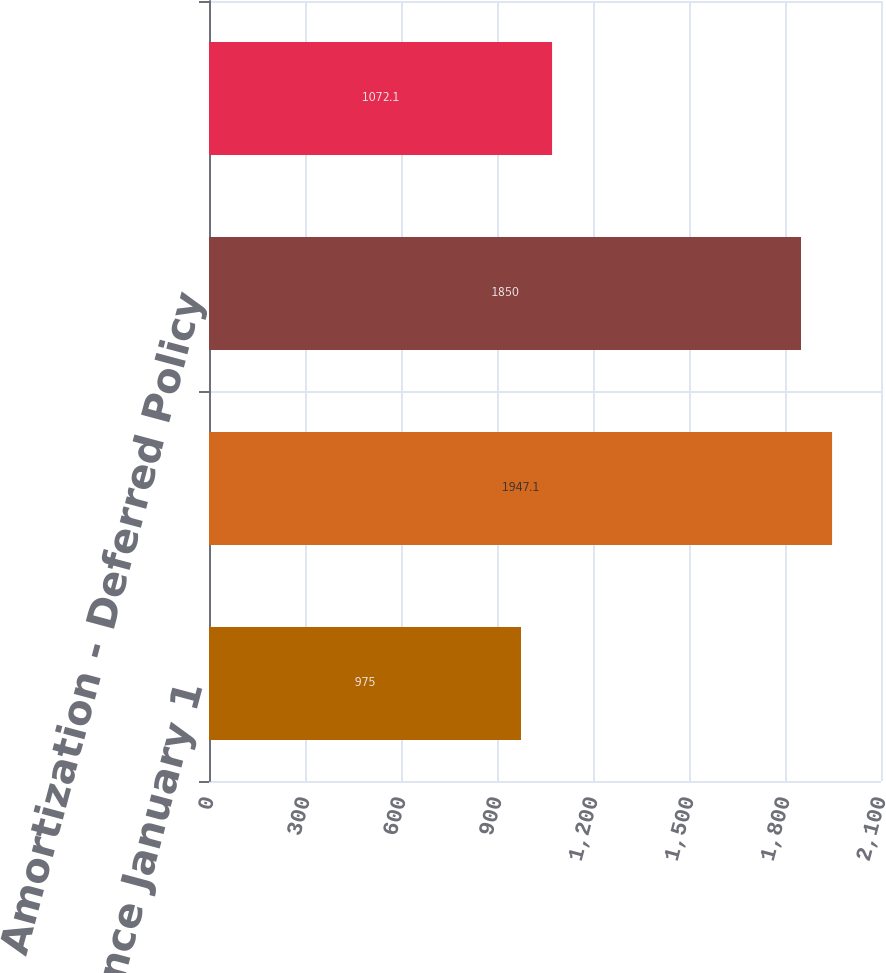Convert chart. <chart><loc_0><loc_0><loc_500><loc_500><bar_chart><fcel>Balance January 1<fcel>Capitalization<fcel>Amortization - Deferred Policy<fcel>Balance December 31<nl><fcel>975<fcel>1947.1<fcel>1850<fcel>1072.1<nl></chart> 